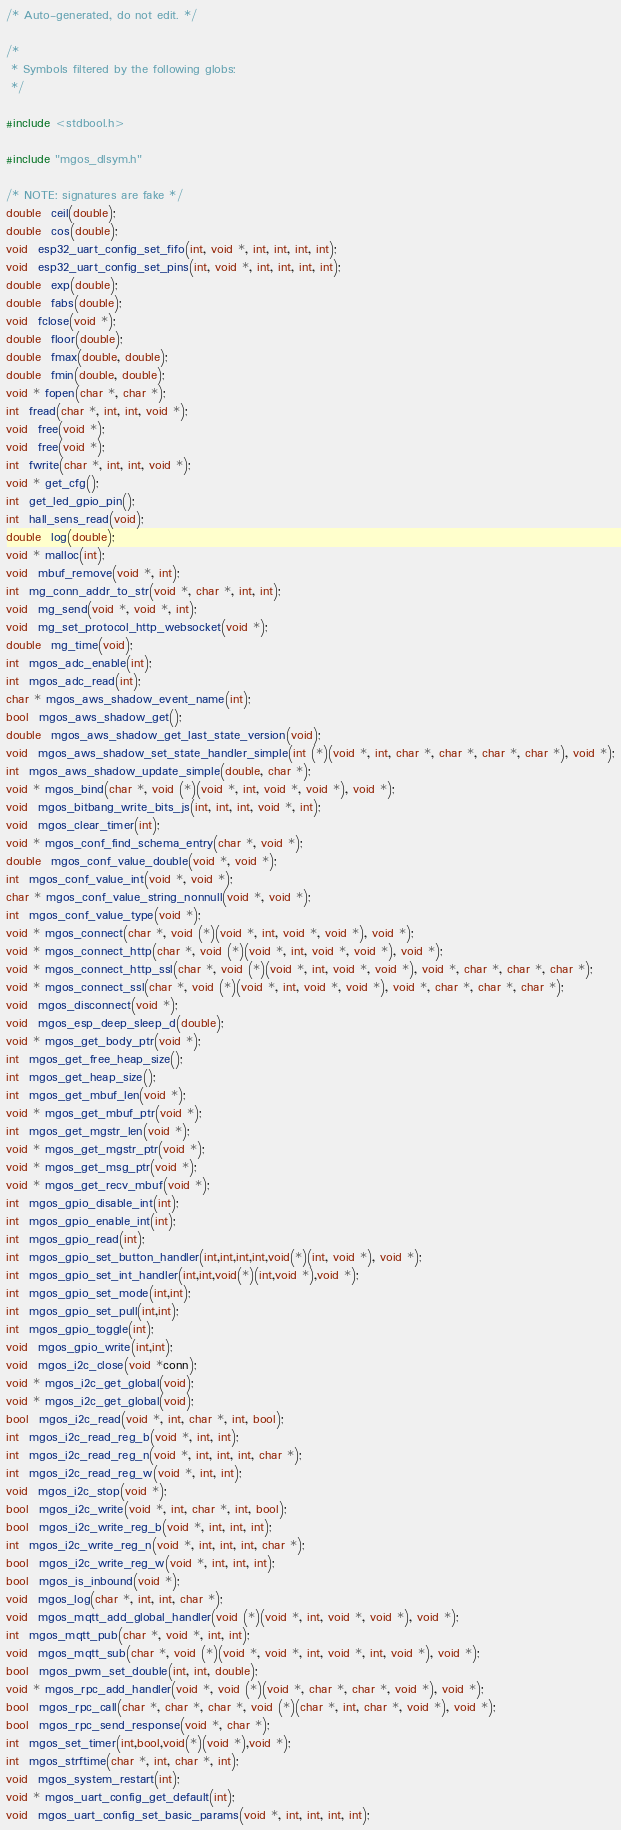Convert code to text. <code><loc_0><loc_0><loc_500><loc_500><_C_>/* Auto-generated, do not edit. */

/*
 * Symbols filtered by the following globs:
 */

#include <stdbool.h>

#include "mgos_dlsym.h"

/* NOTE: signatures are fake */
double  ceil(double);
double  cos(double);
void  esp32_uart_config_set_fifo(int, void *, int, int, int, int);
void  esp32_uart_config_set_pins(int, void *, int, int, int, int);
double  exp(double);
double  fabs(double);
void  fclose(void *);
double  floor(double);
double  fmax(double, double);
double  fmin(double, double);
void * fopen(char *, char *);
int  fread(char *, int, int, void *);
void  free(void *);
void  free(void *);
int  fwrite(char *, int, int, void *);
void * get_cfg();
int  get_led_gpio_pin();
int  hall_sens_read(void);
double  log(double);
void * malloc(int);
void  mbuf_remove(void *, int);
int  mg_conn_addr_to_str(void *, char *, int, int);
void  mg_send(void *, void *, int);
void  mg_set_protocol_http_websocket(void *);
double  mg_time(void);
int  mgos_adc_enable(int);
int  mgos_adc_read(int);
char * mgos_aws_shadow_event_name(int);
bool  mgos_aws_shadow_get();
double  mgos_aws_shadow_get_last_state_version(void);
void  mgos_aws_shadow_set_state_handler_simple(int (*)(void *, int, char *, char *, char *, char *), void *);
int  mgos_aws_shadow_update_simple(double, char *);
void * mgos_bind(char *, void (*)(void *, int, void *, void *), void *);
void  mgos_bitbang_write_bits_js(int, int, int, void *, int);
void  mgos_clear_timer(int);
void * mgos_conf_find_schema_entry(char *, void *);
double  mgos_conf_value_double(void *, void *);
int  mgos_conf_value_int(void *, void *);
char * mgos_conf_value_string_nonnull(void *, void *);
int  mgos_conf_value_type(void *);
void * mgos_connect(char *, void (*)(void *, int, void *, void *), void *);
void * mgos_connect_http(char *, void (*)(void *, int, void *, void *), void *);
void * mgos_connect_http_ssl(char *, void (*)(void *, int, void *, void *), void *, char *, char *, char *);
void * mgos_connect_ssl(char *, void (*)(void *, int, void *, void *), void *, char *, char *, char *);
void  mgos_disconnect(void *);
void  mgos_esp_deep_sleep_d(double);
void * mgos_get_body_ptr(void *);
int  mgos_get_free_heap_size();
int  mgos_get_heap_size();
int  mgos_get_mbuf_len(void *);
void * mgos_get_mbuf_ptr(void *);
int  mgos_get_mgstr_len(void *);
void * mgos_get_mgstr_ptr(void *);
void * mgos_get_msg_ptr(void *);
void * mgos_get_recv_mbuf(void *);
int  mgos_gpio_disable_int(int);
int  mgos_gpio_enable_int(int);
int  mgos_gpio_read(int);
int  mgos_gpio_set_button_handler(int,int,int,int,void(*)(int, void *), void *);
int  mgos_gpio_set_int_handler(int,int,void(*)(int,void *),void *);
int  mgos_gpio_set_mode(int,int);
int  mgos_gpio_set_pull(int,int);
int  mgos_gpio_toggle(int);
void  mgos_gpio_write(int,int);
void  mgos_i2c_close(void *conn);
void * mgos_i2c_get_global(void);
void * mgos_i2c_get_global(void);
bool  mgos_i2c_read(void *, int, char *, int, bool);
int  mgos_i2c_read_reg_b(void *, int, int);
int  mgos_i2c_read_reg_n(void *, int, int, int, char *);
int  mgos_i2c_read_reg_w(void *, int, int);
void  mgos_i2c_stop(void *);
bool  mgos_i2c_write(void *, int, char *, int, bool);
bool  mgos_i2c_write_reg_b(void *, int, int, int);
int  mgos_i2c_write_reg_n(void *, int, int, int, char *);
bool  mgos_i2c_write_reg_w(void *, int, int, int);
bool  mgos_is_inbound(void *);
void  mgos_log(char *, int, int, char *);
void  mgos_mqtt_add_global_handler(void (*)(void *, int, void *, void *), void *);
int  mgos_mqtt_pub(char *, void *, int, int);
void  mgos_mqtt_sub(char *, void (*)(void *, void *, int, void *, int, void *), void *);
bool  mgos_pwm_set_double(int, int, double);
void * mgos_rpc_add_handler(void *, void (*)(void *, char *, char *, void *), void *);
bool  mgos_rpc_call(char *, char *, char *, void (*)(char *, int, char *, void *), void *);
bool  mgos_rpc_send_response(void *, char *);
int  mgos_set_timer(int,bool,void(*)(void *),void *);
int  mgos_strftime(char *, int, char *, int);
void  mgos_system_restart(int);
void * mgos_uart_config_get_default(int);
void  mgos_uart_config_set_basic_params(void *, int, int, int, int);</code> 